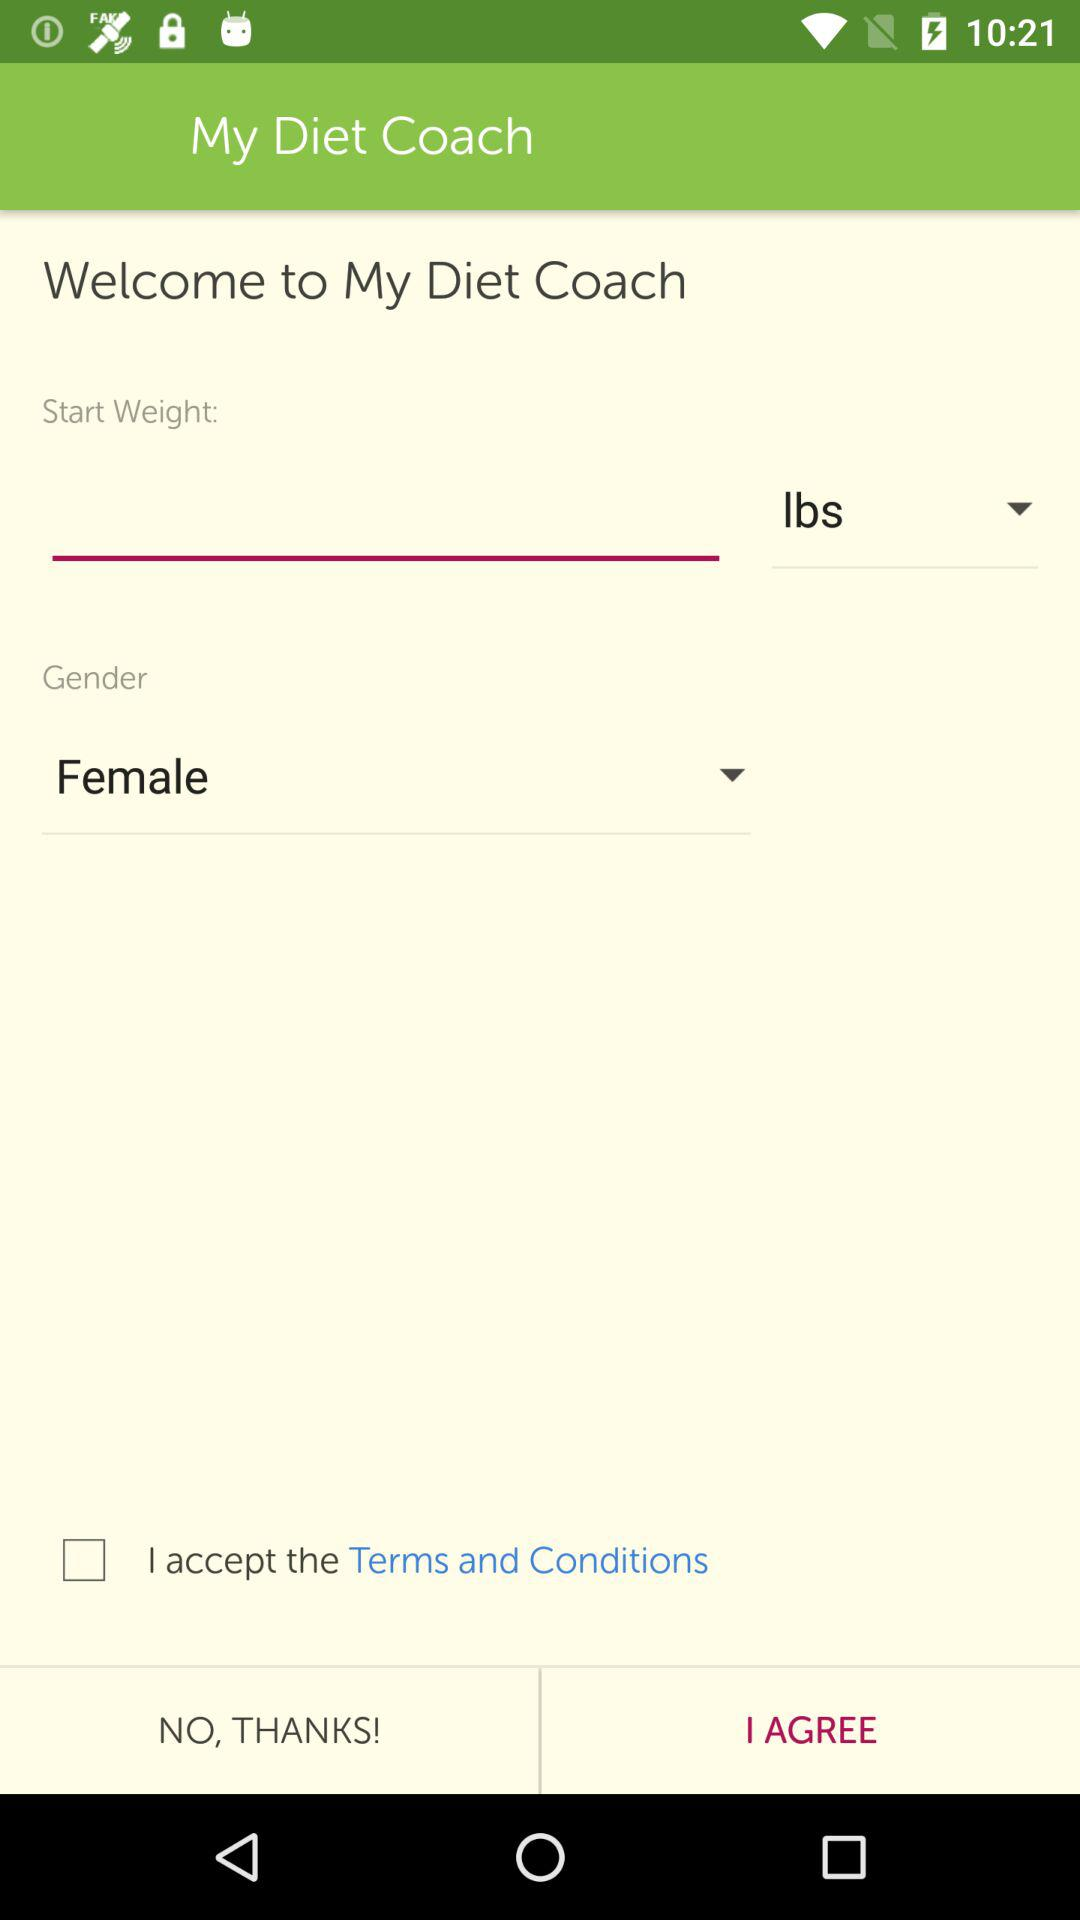Which gender is selected? The selected gender is female. 